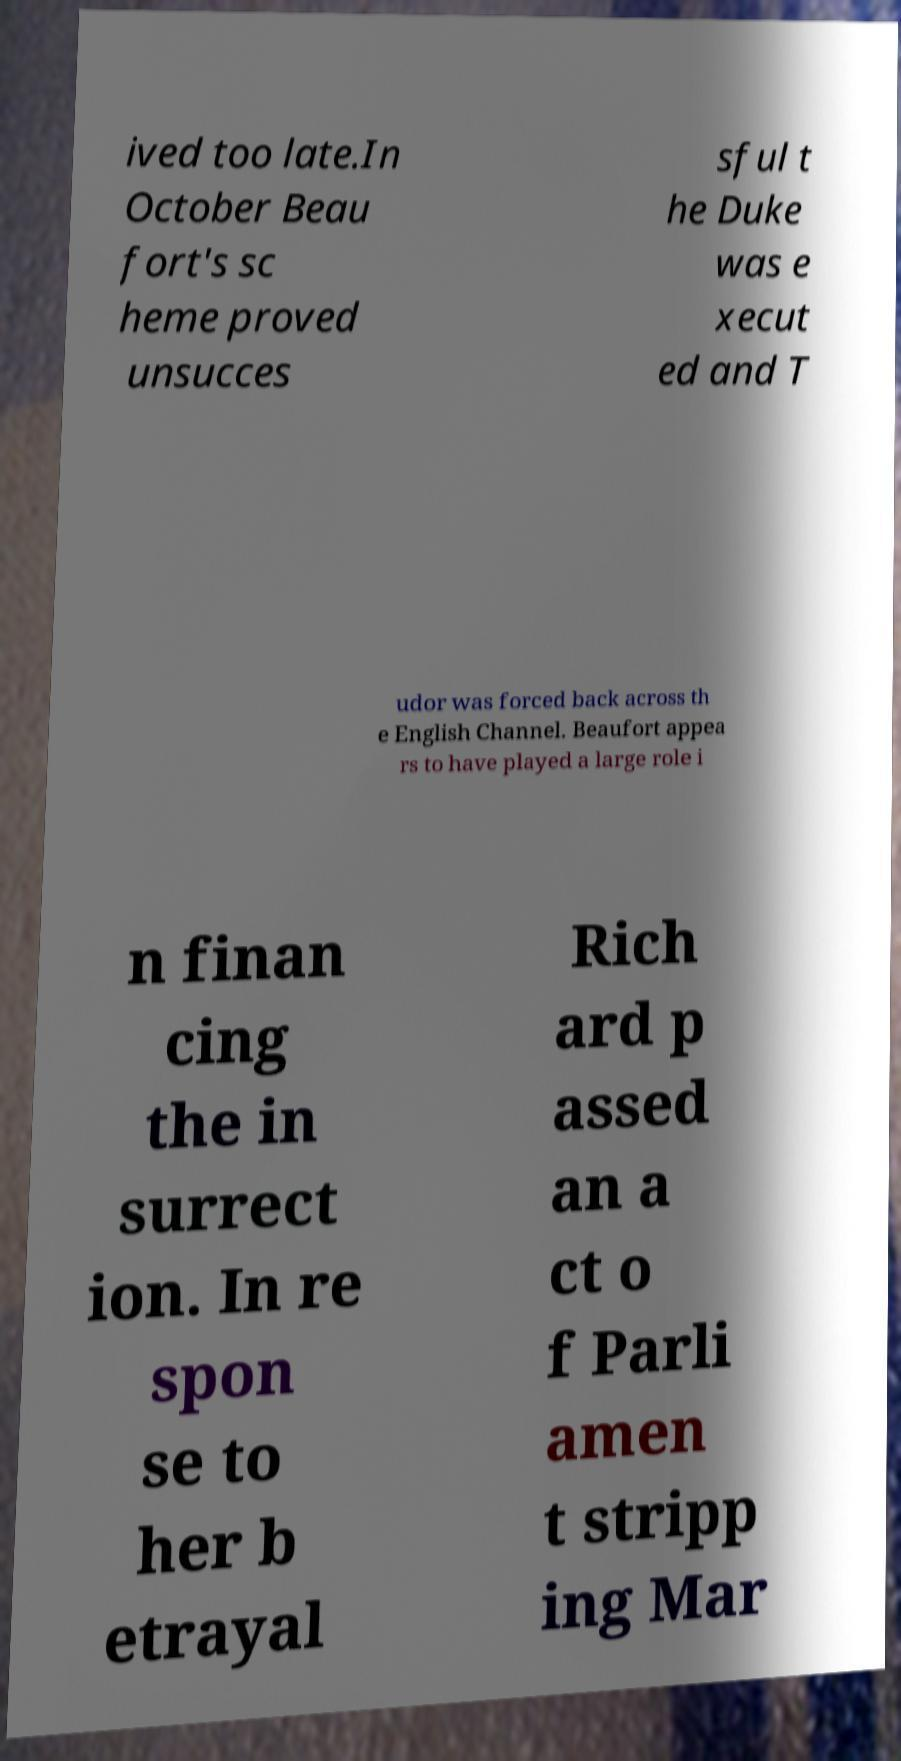Could you assist in decoding the text presented in this image and type it out clearly? ived too late.In October Beau fort's sc heme proved unsucces sful t he Duke was e xecut ed and T udor was forced back across th e English Channel. Beaufort appea rs to have played a large role i n finan cing the in surrect ion. In re spon se to her b etrayal Rich ard p assed an a ct o f Parli amen t stripp ing Mar 